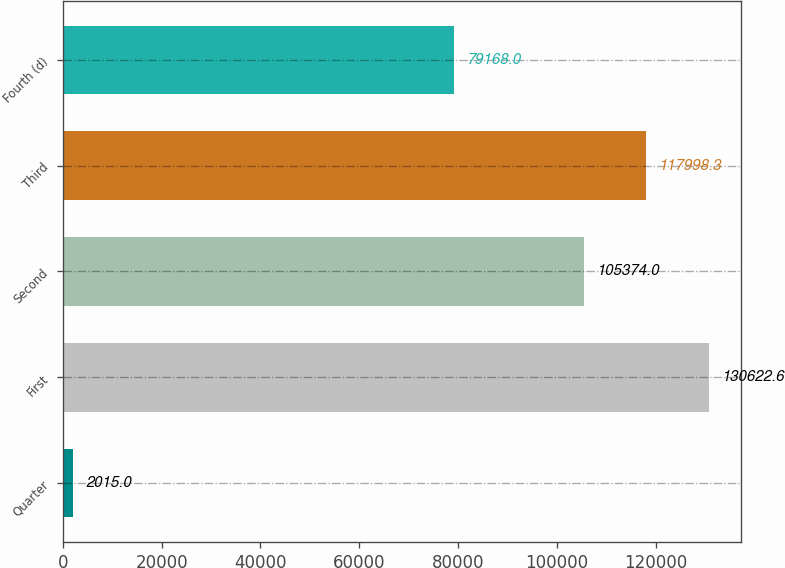Convert chart to OTSL. <chart><loc_0><loc_0><loc_500><loc_500><bar_chart><fcel>Quarter<fcel>First<fcel>Second<fcel>Third<fcel>Fourth (d)<nl><fcel>2015<fcel>130623<fcel>105374<fcel>117998<fcel>79168<nl></chart> 